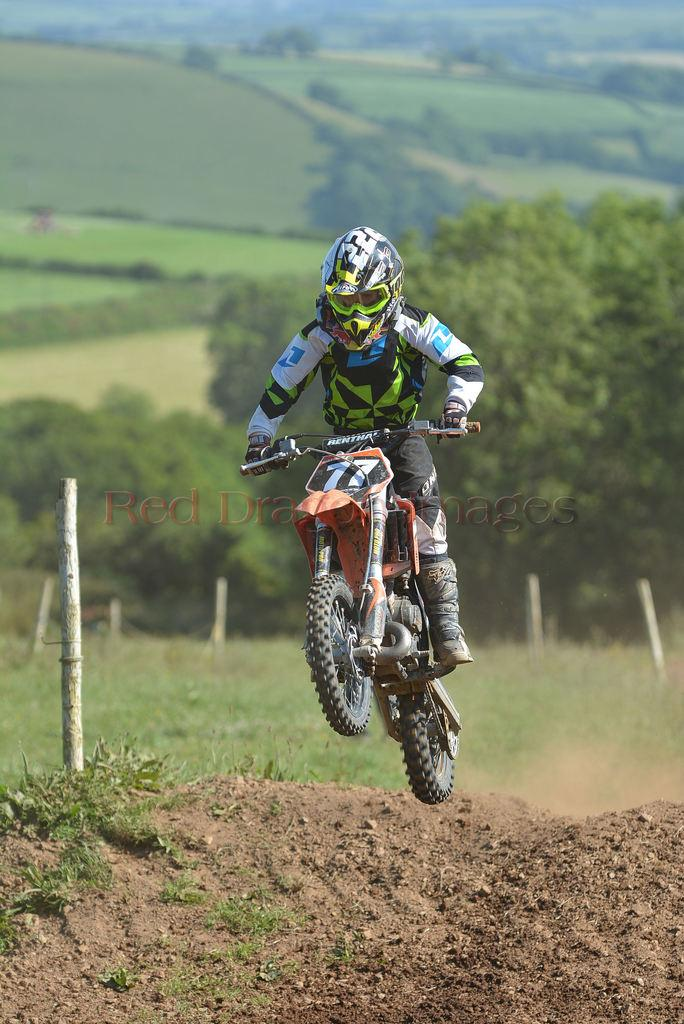What is the main subject of the image? There is a person riding a bike in the image. Where is the person riding the bike located? The person is in a hill station. What type of vegetation can be seen in the image? There are trees visible in the image. What type of ground surface is visible in the image? There is grass visible in the image. Can you tell me how many babies are holding a drink in the image? There are no babies or drinks present in the image. 